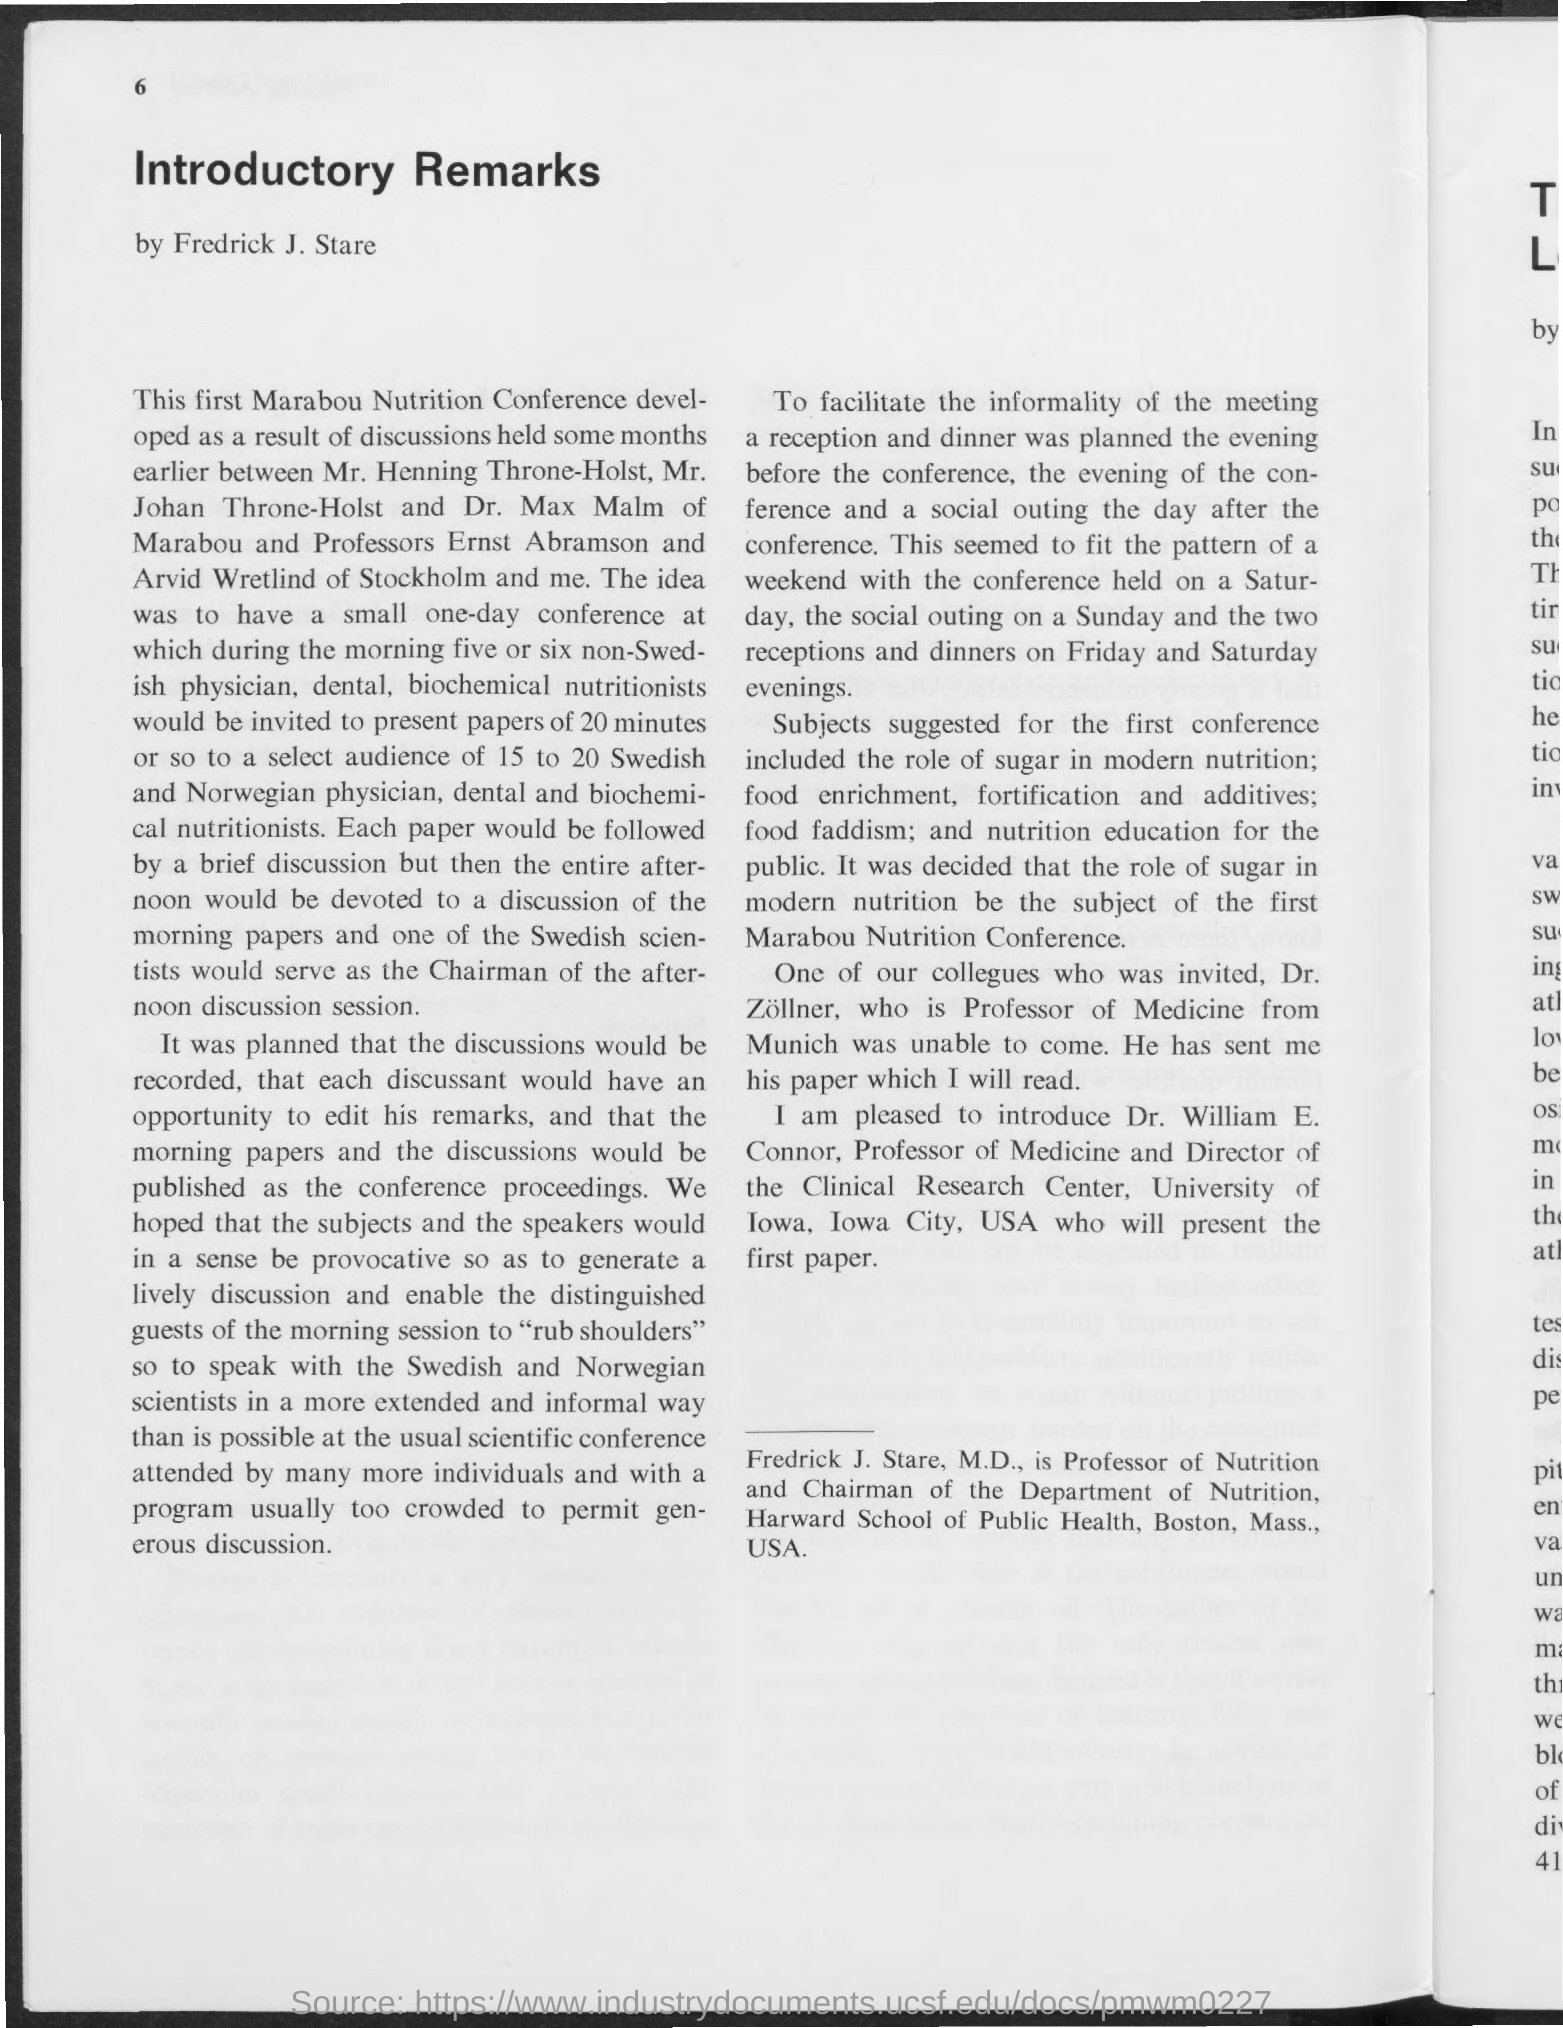What is the title of the document?
Keep it short and to the point. Introductory Remarks. 